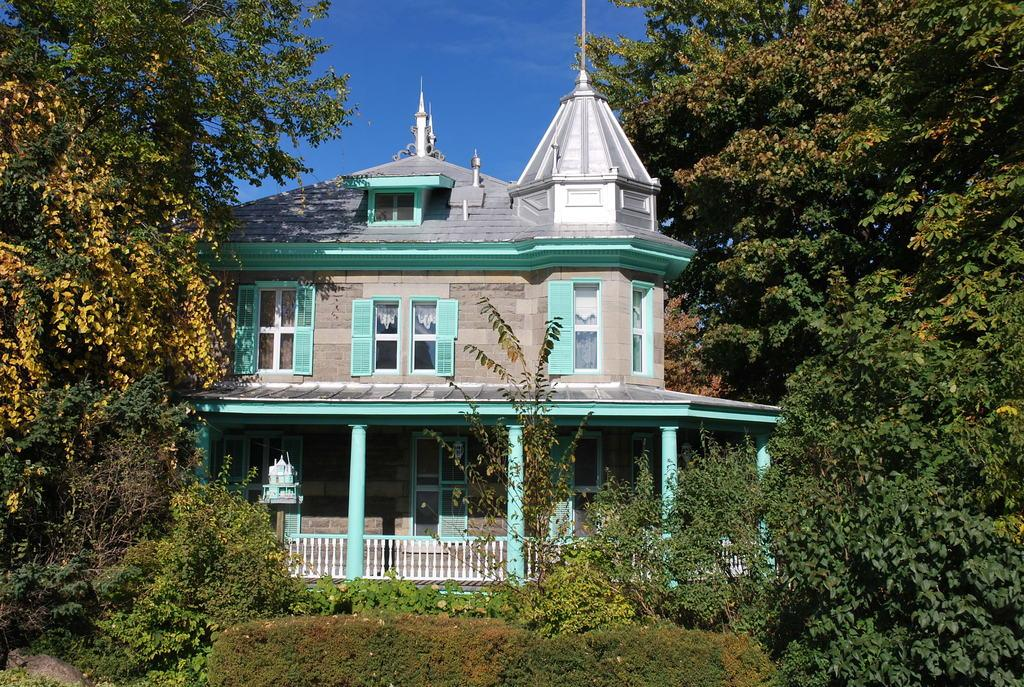What type of natural elements can be seen in the image? There are trees and plants in the image. What type of man-made structure is visible in the image? There is a building in the image. What architectural feature can be seen in the image? There is a railing and pillars in the image. What is visible in the background of the image? The sky is visible in the background of the image. What is the color of the sky in the image? The color of the sky is blue. What type of comb can be seen in the image? There is no comb present in the image. What invention is being demonstrated in the image? There is no invention being demonstrated in the image. 